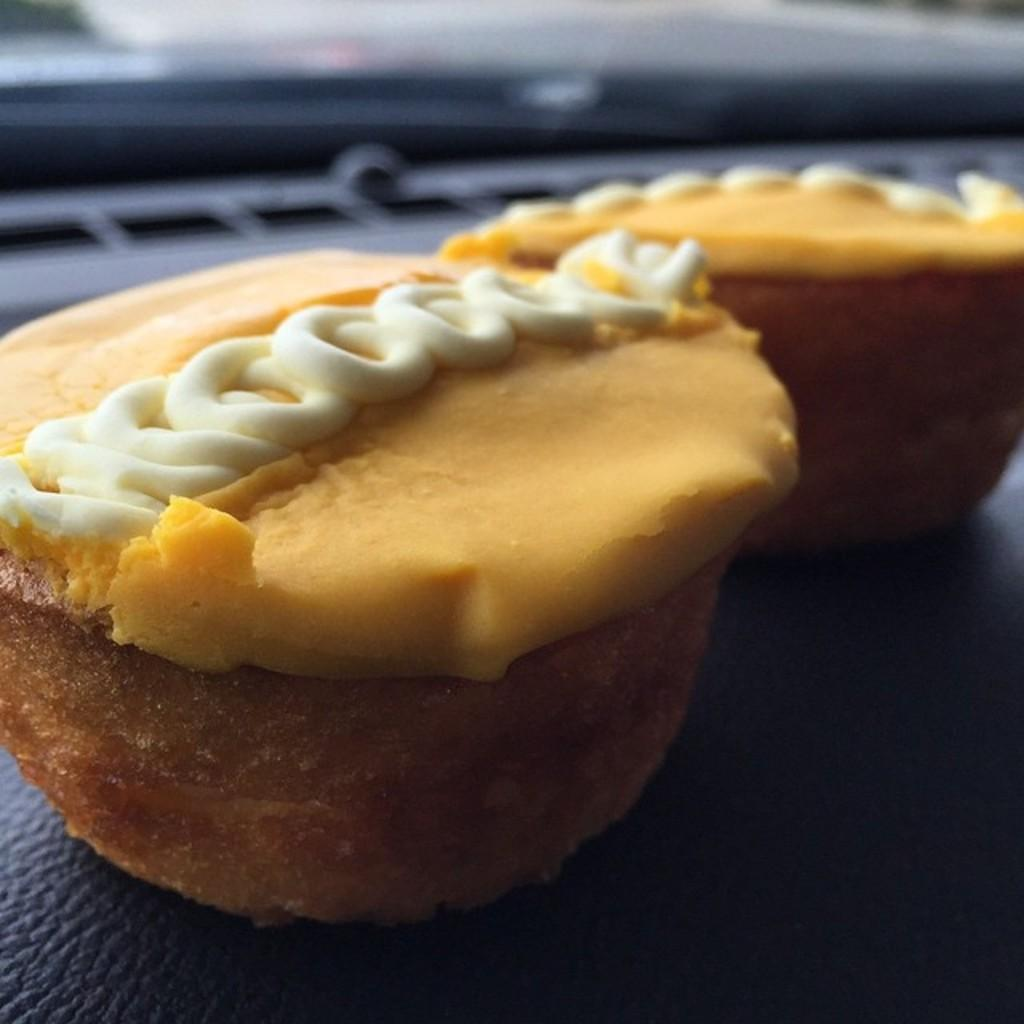How many cupcakes are visible in the image? There are two cupcakes in the image. What is the color of the surface on which the cupcakes are placed? The cupcakes are on a black colored surface. Can you describe the background of the image? The background of the image is blurred. What type of joke is being told by the snails in the image? There are no snails present in the image, so no jokes can be told by them. 